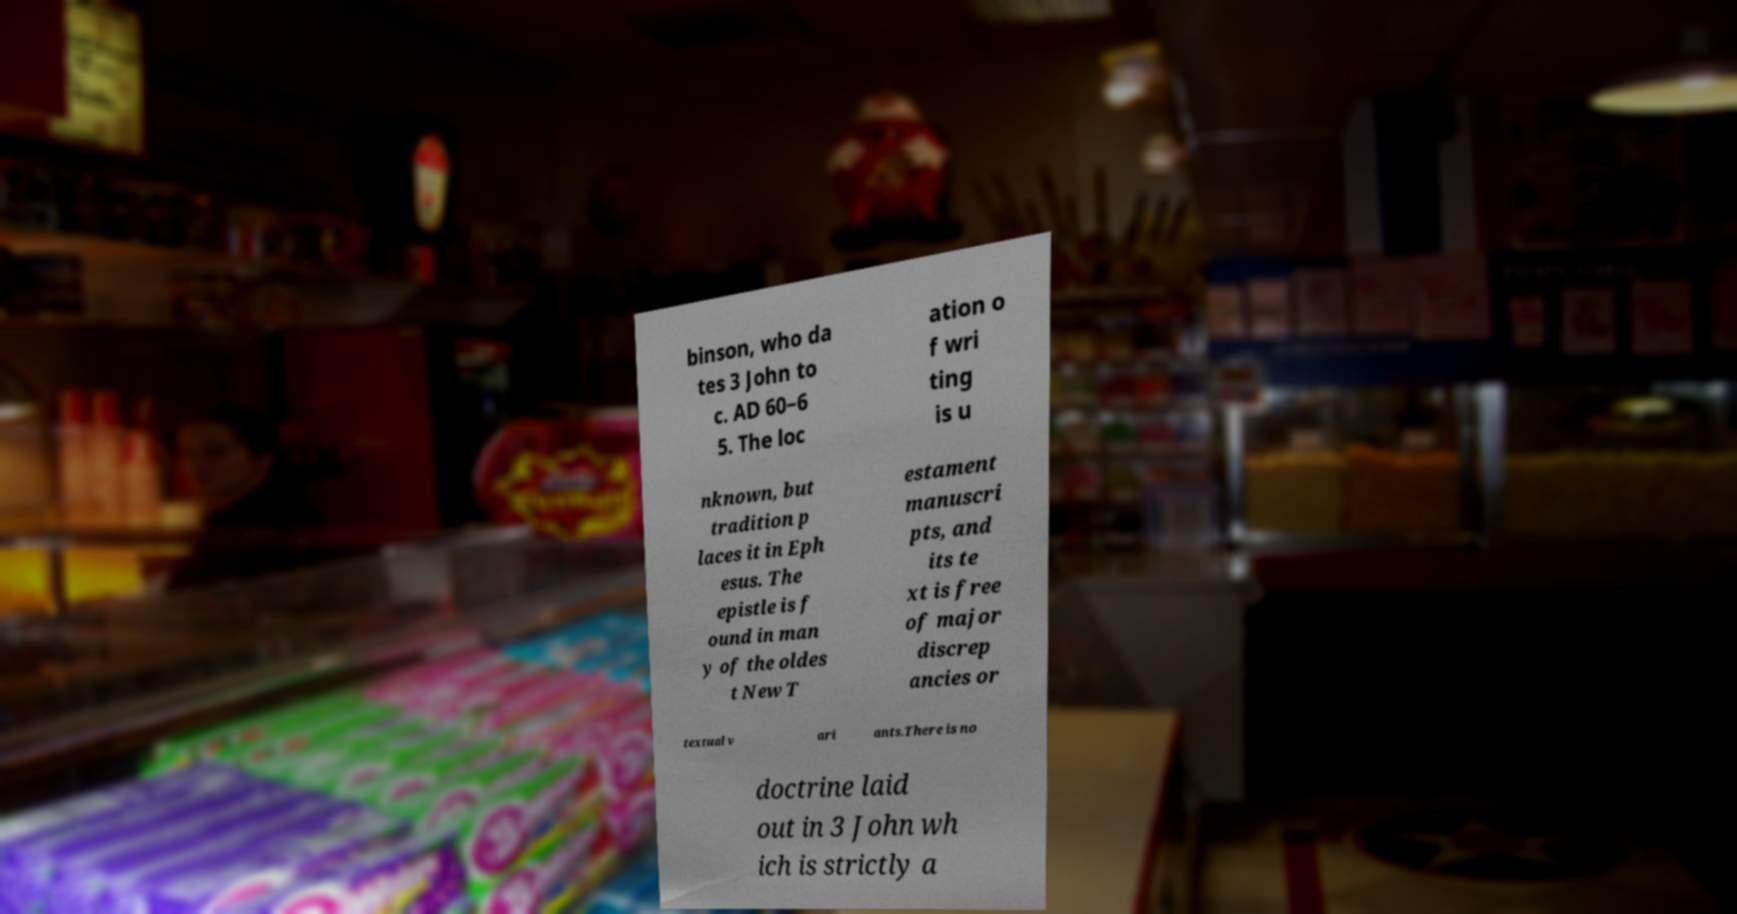Can you accurately transcribe the text from the provided image for me? binson, who da tes 3 John to c. AD 60–6 5. The loc ation o f wri ting is u nknown, but tradition p laces it in Eph esus. The epistle is f ound in man y of the oldes t New T estament manuscri pts, and its te xt is free of major discrep ancies or textual v ari ants.There is no doctrine laid out in 3 John wh ich is strictly a 